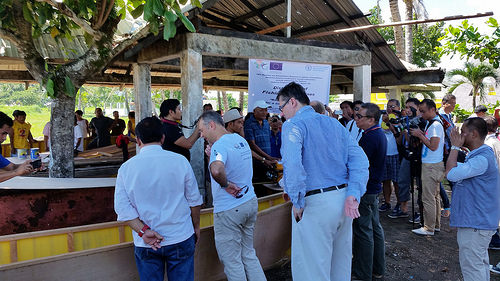<image>
Is the man on the man? No. The man is not positioned on the man. They may be near each other, but the man is not supported by or resting on top of the man. 